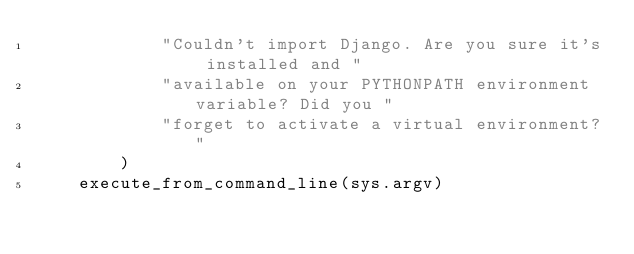Convert code to text. <code><loc_0><loc_0><loc_500><loc_500><_Python_>            "Couldn't import Django. Are you sure it's installed and "
            "available on your PYTHONPATH environment variable? Did you "
            "forget to activate a virtual environment?"
        )
    execute_from_command_line(sys.argv)
</code> 